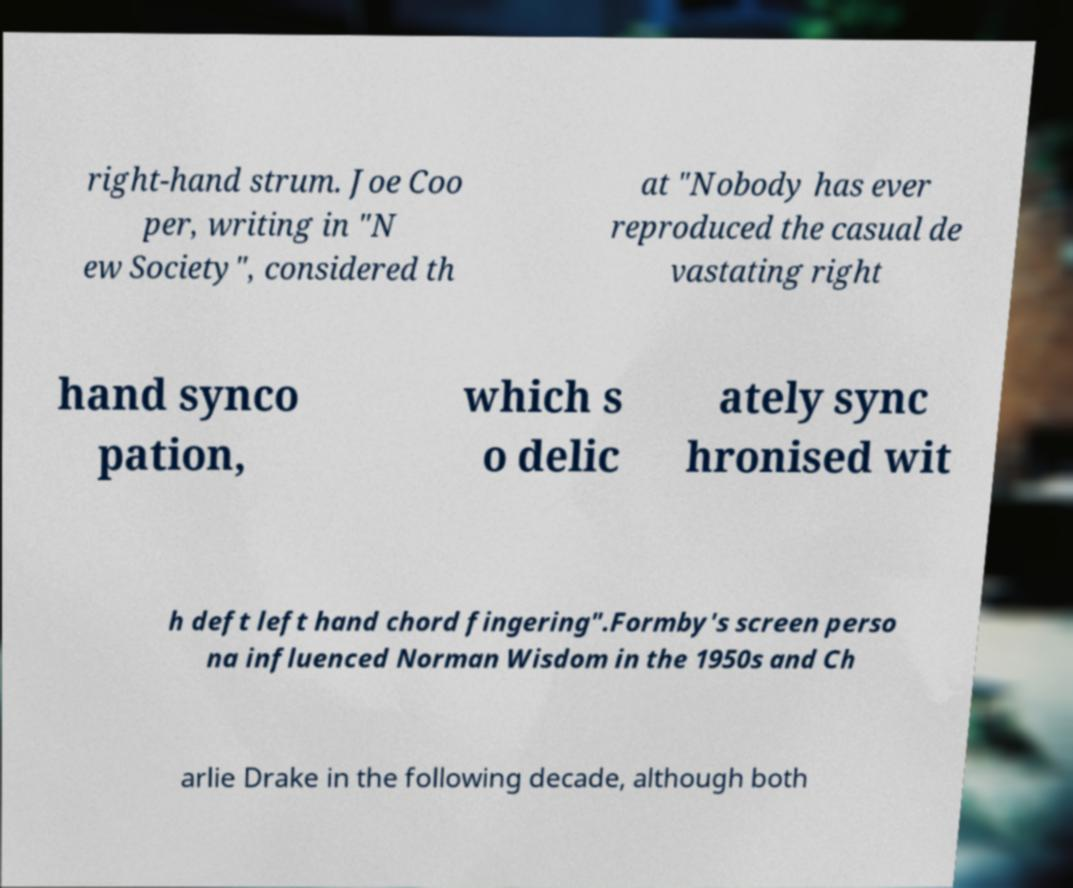Can you read and provide the text displayed in the image?This photo seems to have some interesting text. Can you extract and type it out for me? right-hand strum. Joe Coo per, writing in "N ew Society", considered th at "Nobody has ever reproduced the casual de vastating right hand synco pation, which s o delic ately sync hronised wit h deft left hand chord fingering".Formby's screen perso na influenced Norman Wisdom in the 1950s and Ch arlie Drake in the following decade, although both 